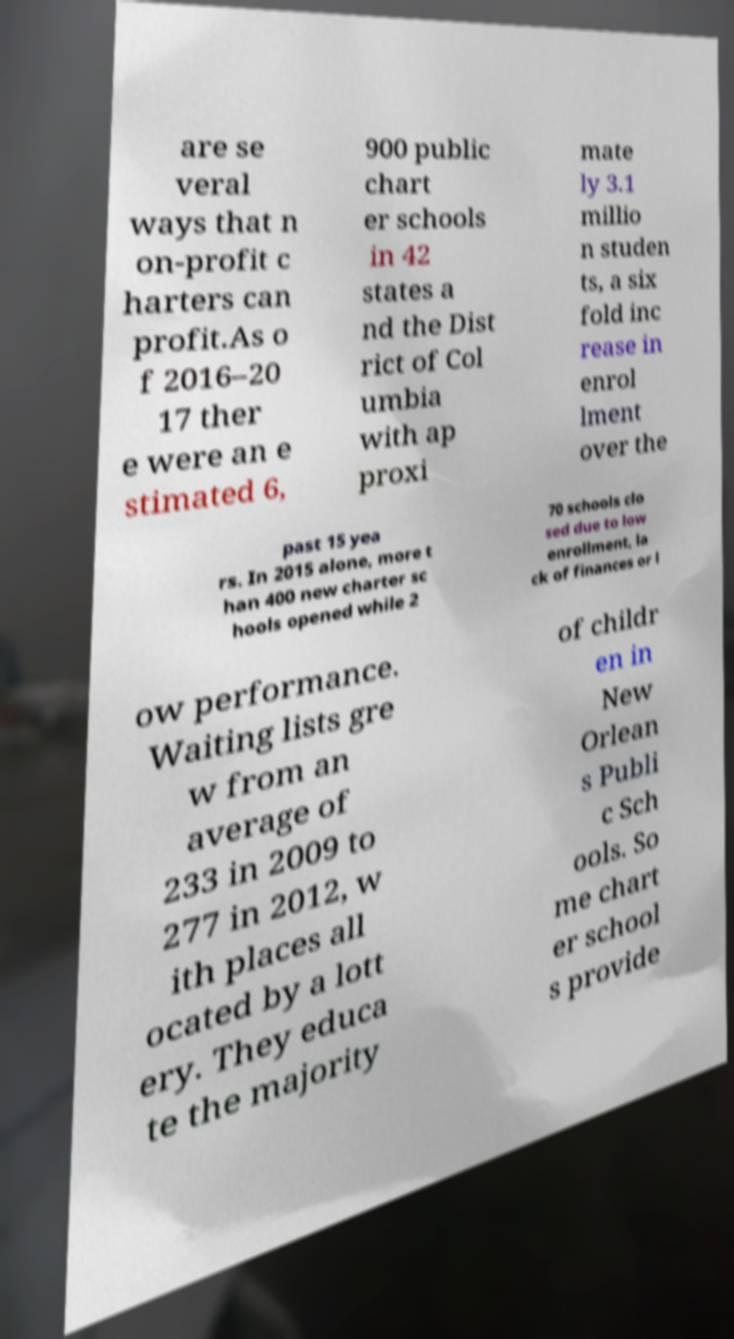Could you assist in decoding the text presented in this image and type it out clearly? are se veral ways that n on-profit c harters can profit.As o f 2016–20 17 ther e were an e stimated 6, 900 public chart er schools in 42 states a nd the Dist rict of Col umbia with ap proxi mate ly 3.1 millio n studen ts, a six fold inc rease in enrol lment over the past 15 yea rs. In 2015 alone, more t han 400 new charter sc hools opened while 2 70 schools clo sed due to low enrollment, la ck of finances or l ow performance. Waiting lists gre w from an average of 233 in 2009 to 277 in 2012, w ith places all ocated by a lott ery. They educa te the majority of childr en in New Orlean s Publi c Sch ools. So me chart er school s provide 